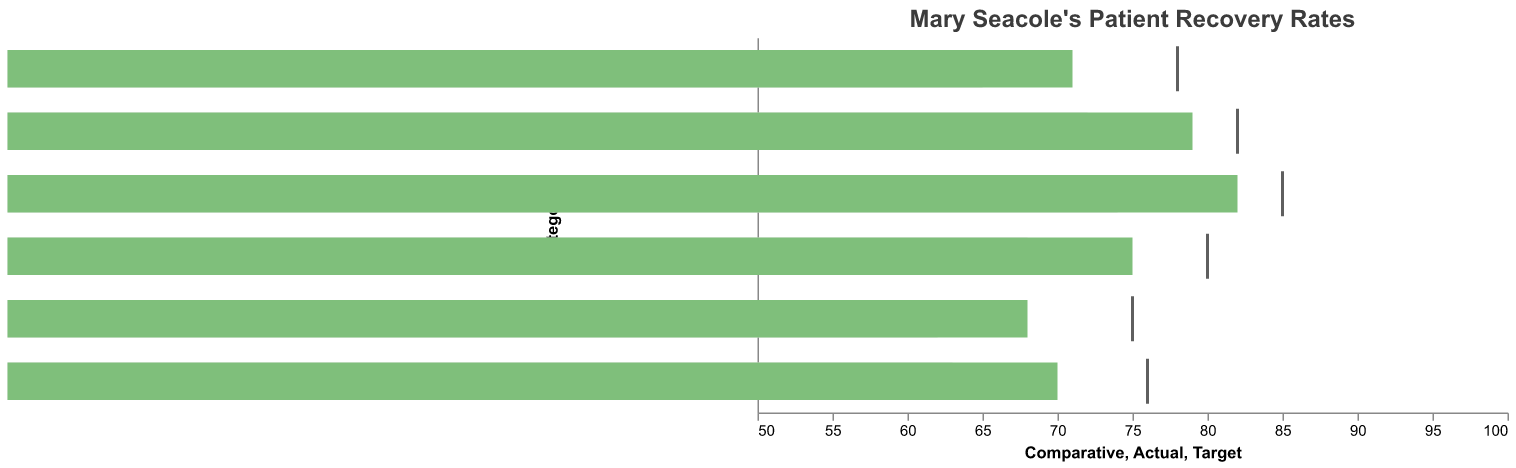What is the title of the chart? The title of the chart appears at the top and reads "Mary Seacole's Patient Recovery Rates."
Answer: Mary Seacole's Patient Recovery Rates What color represents the "Actual" recovery rate in the chart? The "Actual" recovery rate is represented by green bars.
Answer: Green How many categories of patient recovery rates are shown in the chart? The categories of patient recovery rates are listed on the y-axis, and they include Overall Recovery Rate, Fever Cases, Wound Infections, Cholera Patients, Dysentery Cases, and Yellow Fever, totaling six categories.
Answer: Six Which category has the highest "Actual" recovery rate? By comparing the heights of the green bars, "Fever Cases" has the highest "Actual" recovery rate, with a value of 82.
Answer: Fever Cases What is the "Target" recovery rate for "Fever Cases"? The "Target" for "Fever Cases" is marked by a black tick mark above the green bar at the value of 85.
Answer: 85 How does the "Comparative" recovery rate for "Cholera Patients" compare to the "Actual" recovery rate for the same category? The "Comparative" recovery rate for "Cholera Patients" is 65, while the "Actual" recovery rate is 71. To compare, subtract 65 from 71 (71 - 65), which shows that the "Actual" recovery rate is 6 higher than the "Comparative" recovery rate.
Answer: 6 higher Which category has the smallest difference between the "Actual" recovery rate and the "Target" recovery rate? Calculate the difference for each category by subtracting the "Actual" recovery rate from the "Target" recovery rate: 
- Overall Recovery Rate: 80 - 75 = 5
- Fever Cases: 85 - 82 = 3
- Wound Infections: 75 - 68 = 7
- Cholera Patients: 78 - 71 = 7
- Dysentery Cases: 82 - 79 = 3
- Yellow Fever: 76 - 70 = 6 
The smallest difference is 3, shared by "Fever Cases" and "Dysentery Cases".
Answer: Fever Cases, Dysentery Cases How does the "Actual" recovery rate for "Wound Infections" compare to the "Comparative" recovery rate for "Dysentery Cases"? The "Actual" recovery rate for "Wound Infections" is 68, and the "Comparative" recovery rate for "Dysentery Cases" is 72. Subtract 68 from 72, which gives a difference of 4, indicating that the "Comparative" recovery rate for "Dysentery Cases" is 4 higher.
Answer: 4 higher What is the average "Actual" recovery rate across all categories? To find the average, sum all "Actual" rates and divide by the number of categories:
(75 + 82 + 68 + 71 + 79 + 70) / 6 = 445 / 6 = 74.17.
Answer: 74.17 